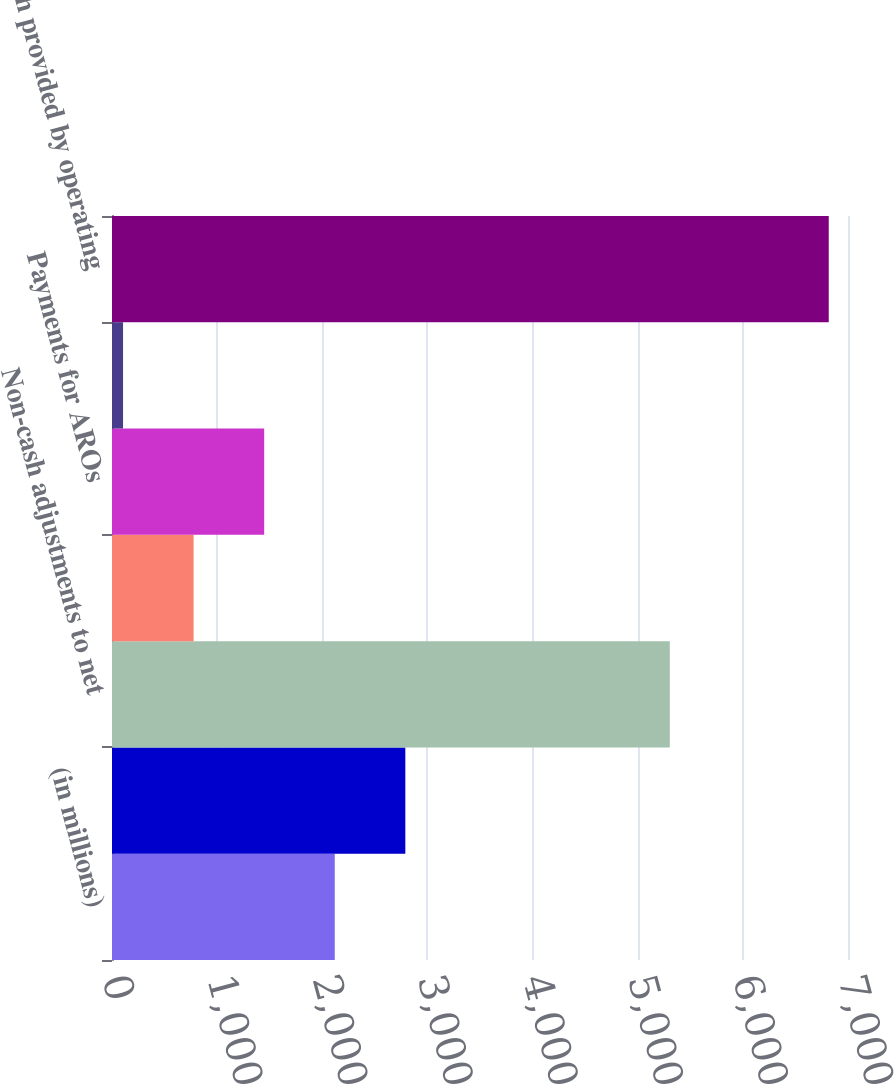<chart> <loc_0><loc_0><loc_500><loc_500><bar_chart><fcel>(in millions)<fcel>Net income<fcel>Non-cash adjustments to net<fcel>Contributions to qualified<fcel>Payments for AROs<fcel>Working capital<fcel>Net cash provided by operating<nl><fcel>2118.6<fcel>2789.8<fcel>5305<fcel>776.2<fcel>1447.4<fcel>105<fcel>6817<nl></chart> 